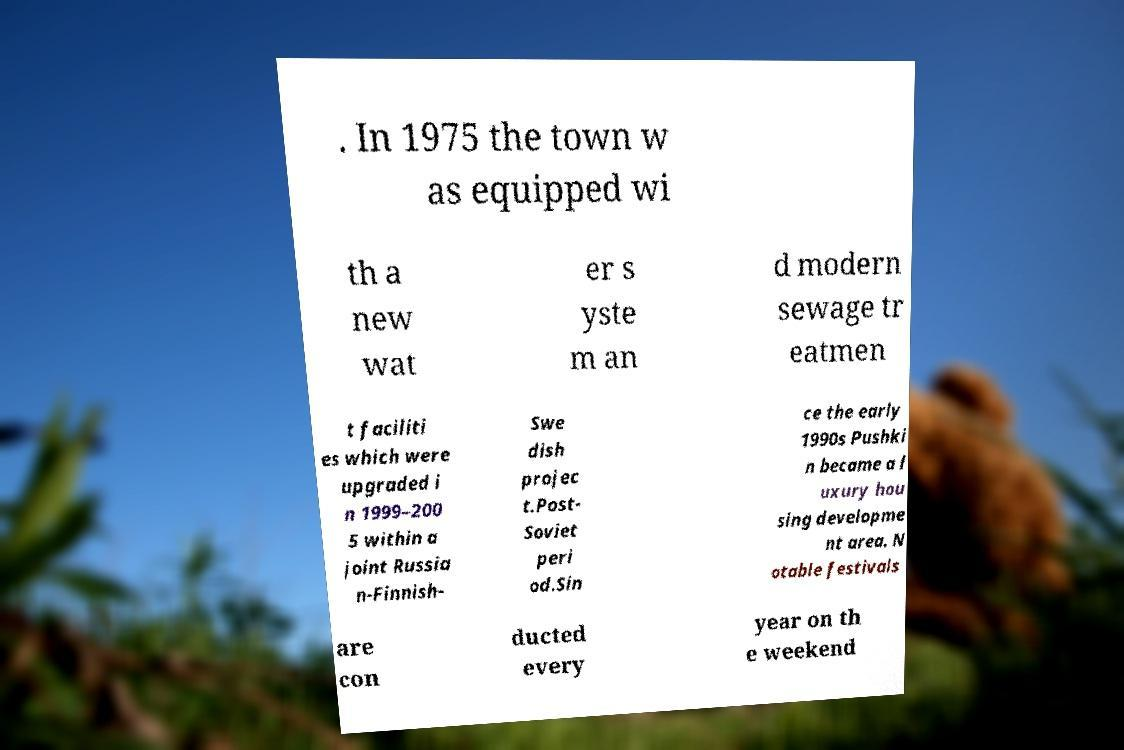I need the written content from this picture converted into text. Can you do that? . In 1975 the town w as equipped wi th a new wat er s yste m an d modern sewage tr eatmen t faciliti es which were upgraded i n 1999–200 5 within a joint Russia n-Finnish- Swe dish projec t.Post- Soviet peri od.Sin ce the early 1990s Pushki n became a l uxury hou sing developme nt area. N otable festivals are con ducted every year on th e weekend 